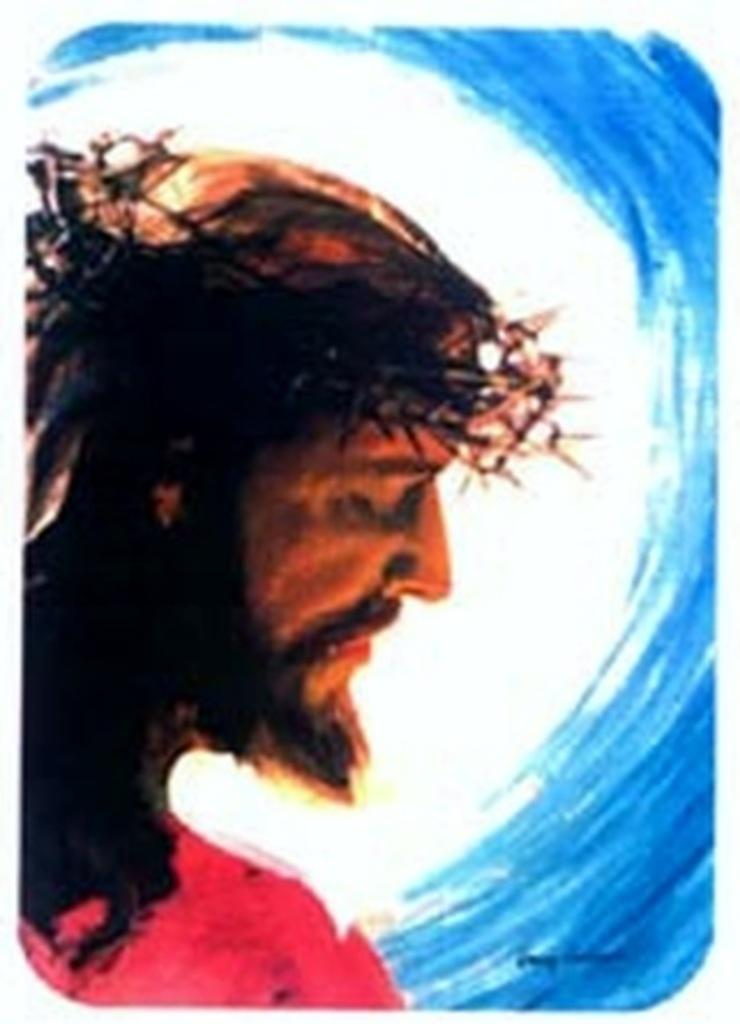What is the main subject of the image? The image contains a depiction of a man. Can you describe the background colors in the image? The background colors are white and blue. What type of beetle can be seen crawling on the man's shoulder in the image? There is no beetle present on the man's shoulder in the image. 